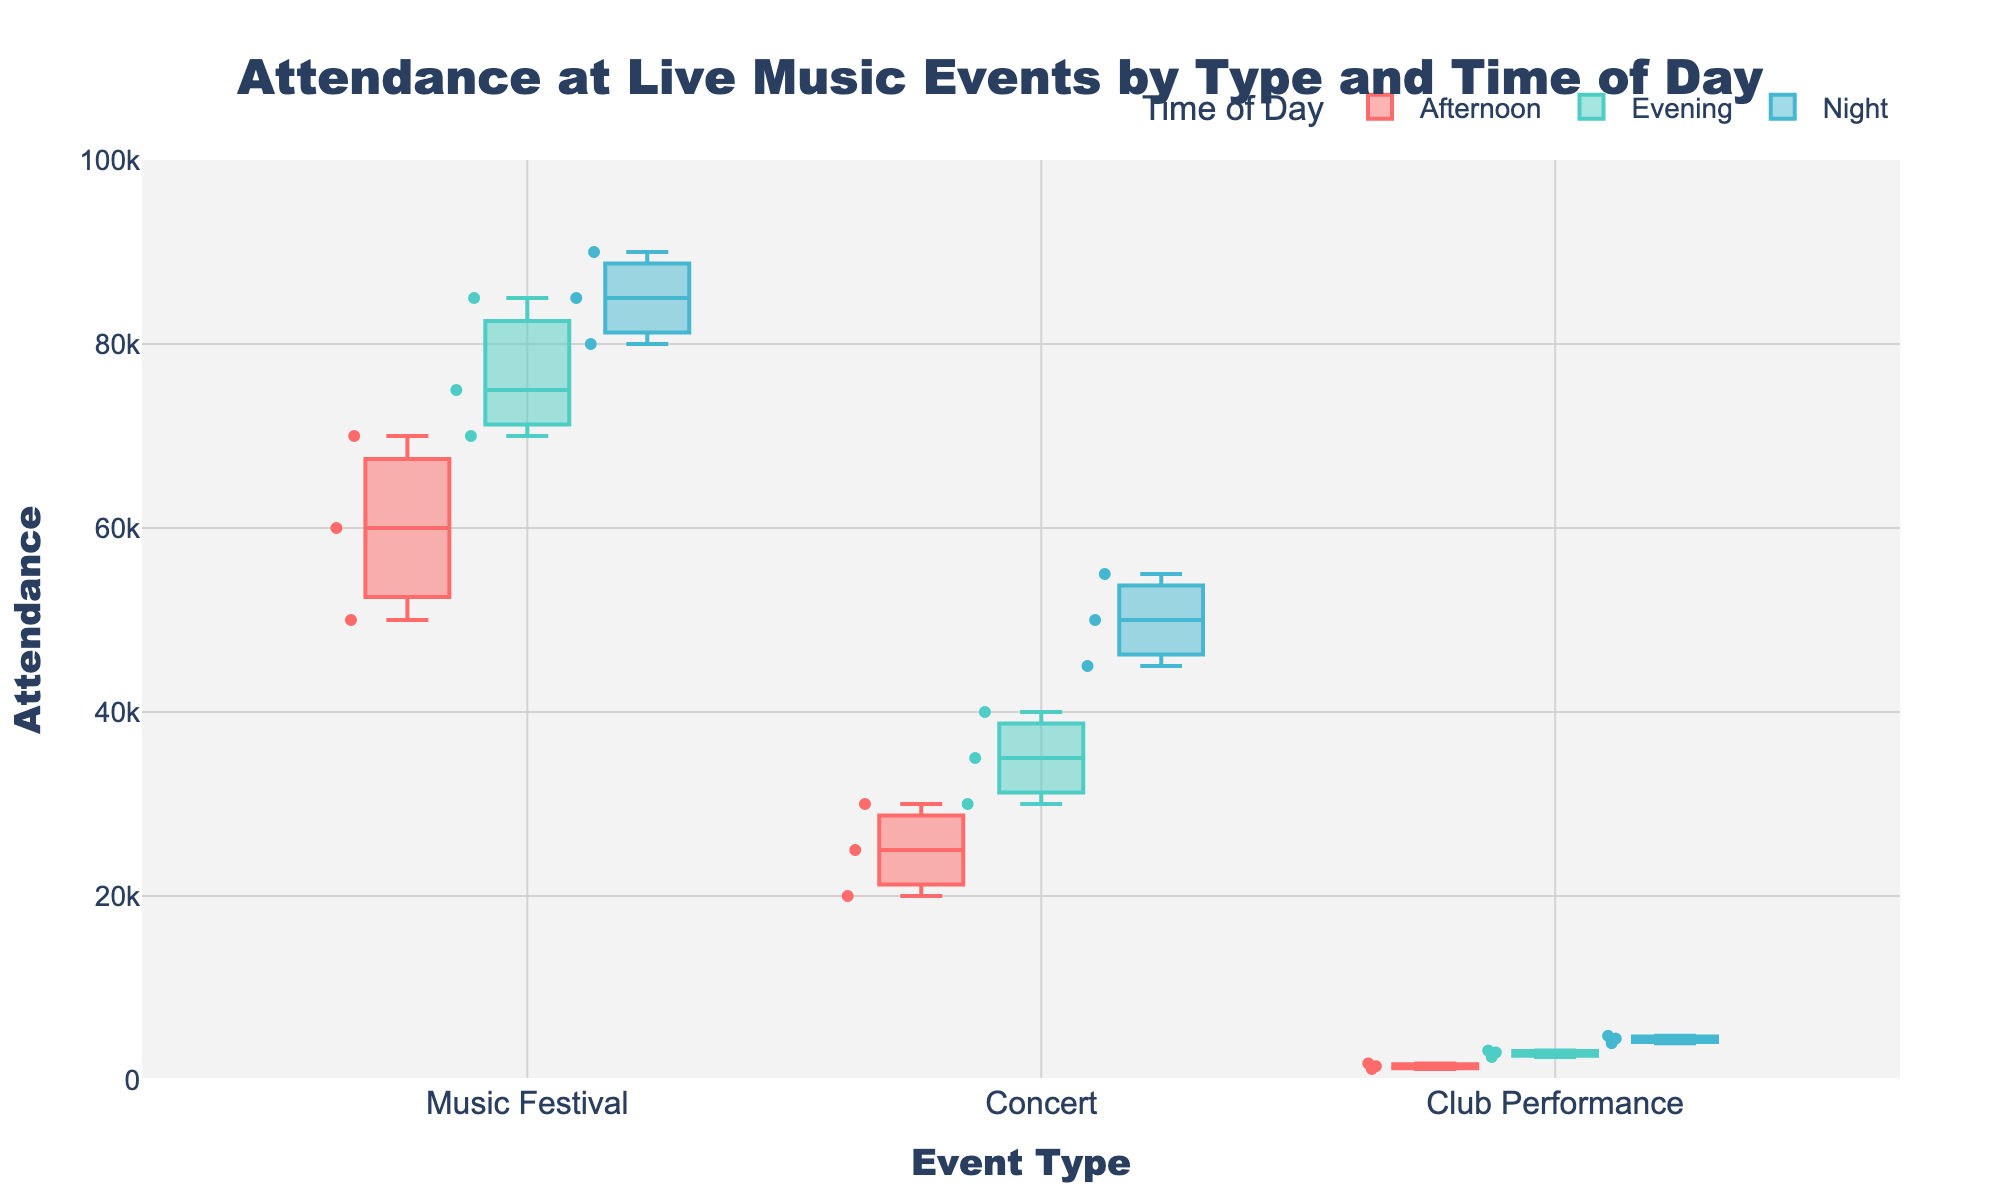What is the title of the figure? The title is located at the top of the figure. It is in a larger font size and centered above the plot area.
Answer: Attendance at Live Music Events by Type and Time of Day What type of live music event has the highest total (summed) attendance for the 'Afternoon' time of day? To find this, sum the 'Afternoon' attendance for each event type and compare. Music Festivals: 60000 + 50000 + 70000 = 180000. Concerts: 25000 + 30000 + 20000 = 75000. Club Performances: 1200 + 1500 + 1800 = 4500. The highest total is for Music Festivals.
Answer: Music Festivals Which type of event shows a greater variance in attendance across different times of day: 'Concerts' or 'Club Performances'? 'Variance' here refers to the spread of attendance numbers across Afternoon, Evening, and Night. Concerts have a wider range (20000 to 55000) compared to Club Performances (1200 to 4800).
Answer: Concerts What is the median attendance for 'Music Festival' events during 'Night'? The median is the middle value when these numbers are sorted. For Night time, Music Festival attendances are 85000, 80000, and 90000. The median is the middle number in this sorted list.
Answer: 85000 Which event type shows the highest attendance during the 'Evening' time of day? Compare the highest Evening attendance values among Music Festivals, Concerts, and Club Performances. The values are 85000 for Music Festivals, 40000 for Concerts, and 3200 for Club Performances.
Answer: Music Festivals Which specific event had the lowest attendance at any time of day? By examining the scatter points, DJ Premier Performance in the Afternoon shows the lowest attendance number of 1200.
Answer: DJ Premier Performance What is the range of attendance for 'Concerts' during the 'Evening' time of day? The range is the difference between the maximum and minimum attendance values. For Evening, Concert attendances range from 30000 to 40000. The range is 40000 - 30000 = 10000.
Answer: 10000 How does the attendance pattern for 'Club Performances' vary compared to 'Music Festivals' and 'Concerts'? Club Performances have significantly lower attendance numbers and less variation through the day compared to Music Festivals and Concerts, which have larger numbers and more variation from Afternoon to Night.
Answer: Lower and less varied Which time of day sees the highest attendance overall? To find this, identify the time of day with the highest attendance values across all event types. 'Night' generally has the highest attendance values.
Answer: Night 